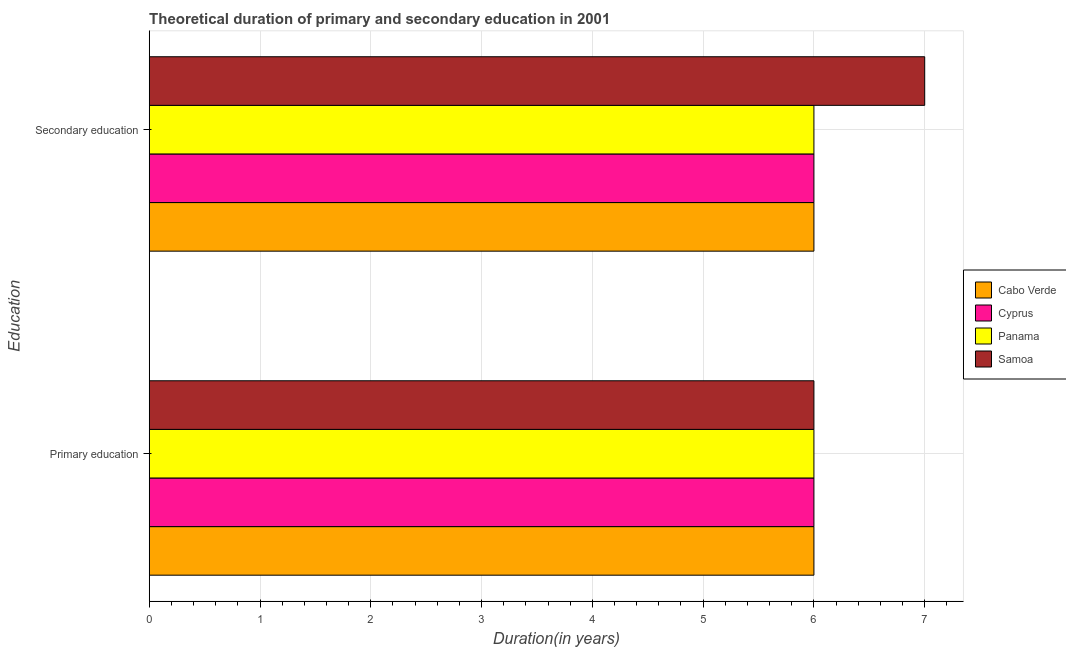Are the number of bars per tick equal to the number of legend labels?
Give a very brief answer. Yes. How many bars are there on the 1st tick from the bottom?
Provide a short and direct response. 4. What is the duration of primary education in Cabo Verde?
Provide a short and direct response. 6. Across all countries, what is the maximum duration of primary education?
Provide a short and direct response. 6. In which country was the duration of secondary education maximum?
Your response must be concise. Samoa. In which country was the duration of primary education minimum?
Offer a terse response. Cabo Verde. What is the total duration of primary education in the graph?
Provide a succinct answer. 24. What is the average duration of primary education per country?
Your answer should be compact. 6. What is the difference between the duration of secondary education and duration of primary education in Samoa?
Make the answer very short. 1. In how many countries, is the duration of primary education greater than 3 years?
Ensure brevity in your answer.  4. What does the 4th bar from the top in Primary education represents?
Offer a very short reply. Cabo Verde. What does the 2nd bar from the bottom in Secondary education represents?
Your answer should be very brief. Cyprus. How many bars are there?
Make the answer very short. 8. Are all the bars in the graph horizontal?
Give a very brief answer. Yes. What is the difference between two consecutive major ticks on the X-axis?
Offer a very short reply. 1. How many legend labels are there?
Provide a short and direct response. 4. How are the legend labels stacked?
Ensure brevity in your answer.  Vertical. What is the title of the graph?
Offer a very short reply. Theoretical duration of primary and secondary education in 2001. What is the label or title of the X-axis?
Your answer should be very brief. Duration(in years). What is the label or title of the Y-axis?
Offer a terse response. Education. What is the Duration(in years) of Cyprus in Primary education?
Your answer should be very brief. 6. What is the Duration(in years) in Panama in Primary education?
Keep it short and to the point. 6. Across all Education, what is the maximum Duration(in years) in Cyprus?
Offer a very short reply. 6. Across all Education, what is the maximum Duration(in years) of Panama?
Give a very brief answer. 6. Across all Education, what is the minimum Duration(in years) of Cabo Verde?
Your answer should be compact. 6. Across all Education, what is the minimum Duration(in years) of Panama?
Your response must be concise. 6. What is the total Duration(in years) in Panama in the graph?
Your answer should be very brief. 12. What is the total Duration(in years) of Samoa in the graph?
Provide a succinct answer. 13. What is the difference between the Duration(in years) in Cabo Verde in Primary education and that in Secondary education?
Provide a succinct answer. 0. What is the difference between the Duration(in years) of Panama in Primary education and that in Secondary education?
Keep it short and to the point. 0. What is the difference between the Duration(in years) of Cabo Verde in Primary education and the Duration(in years) of Cyprus in Secondary education?
Give a very brief answer. 0. What is the difference between the Duration(in years) in Cabo Verde in Primary education and the Duration(in years) in Panama in Secondary education?
Your answer should be compact. 0. What is the difference between the Duration(in years) in Cyprus in Primary education and the Duration(in years) in Samoa in Secondary education?
Provide a succinct answer. -1. What is the average Duration(in years) of Cabo Verde per Education?
Provide a succinct answer. 6. What is the average Duration(in years) of Cyprus per Education?
Give a very brief answer. 6. What is the average Duration(in years) of Panama per Education?
Offer a terse response. 6. What is the average Duration(in years) in Samoa per Education?
Offer a terse response. 6.5. What is the difference between the Duration(in years) in Cabo Verde and Duration(in years) in Cyprus in Primary education?
Ensure brevity in your answer.  0. What is the difference between the Duration(in years) of Cabo Verde and Duration(in years) of Panama in Primary education?
Your response must be concise. 0. What is the difference between the Duration(in years) in Cabo Verde and Duration(in years) in Samoa in Primary education?
Ensure brevity in your answer.  0. What is the difference between the Duration(in years) in Cyprus and Duration(in years) in Panama in Primary education?
Offer a terse response. 0. What is the difference between the Duration(in years) of Cabo Verde and Duration(in years) of Cyprus in Secondary education?
Your response must be concise. 0. What is the difference between the Duration(in years) of Cabo Verde and Duration(in years) of Samoa in Secondary education?
Ensure brevity in your answer.  -1. What is the difference between the Duration(in years) in Cyprus and Duration(in years) in Panama in Secondary education?
Keep it short and to the point. 0. What is the ratio of the Duration(in years) in Cyprus in Primary education to that in Secondary education?
Your response must be concise. 1. What is the difference between the highest and the second highest Duration(in years) of Samoa?
Keep it short and to the point. 1. What is the difference between the highest and the lowest Duration(in years) in Cyprus?
Give a very brief answer. 0. What is the difference between the highest and the lowest Duration(in years) of Samoa?
Keep it short and to the point. 1. 